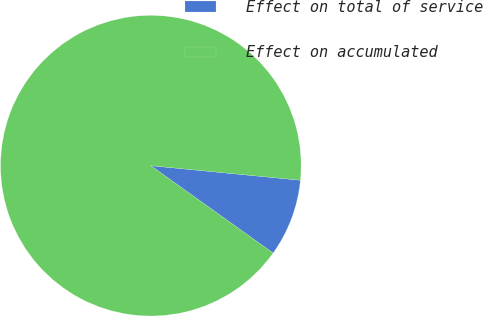Convert chart to OTSL. <chart><loc_0><loc_0><loc_500><loc_500><pie_chart><fcel>Effect on total of service<fcel>Effect on accumulated<nl><fcel>8.33%<fcel>91.67%<nl></chart> 